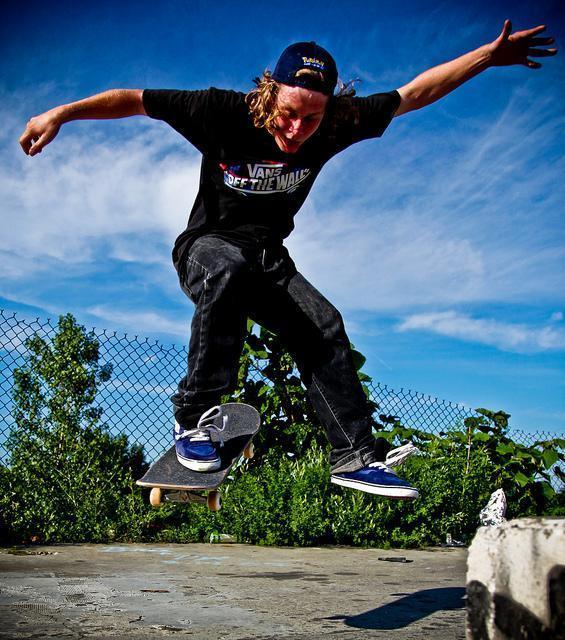How many people are in the photo?
Give a very brief answer. 1. How many baby giraffes are there?
Give a very brief answer. 0. 